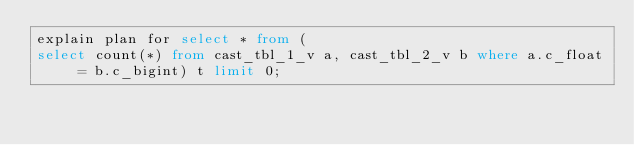<code> <loc_0><loc_0><loc_500><loc_500><_SQL_>explain plan for select * from (
select count(*) from cast_tbl_1_v a, cast_tbl_2_v b where a.c_float = b.c_bigint) t limit 0;
</code> 